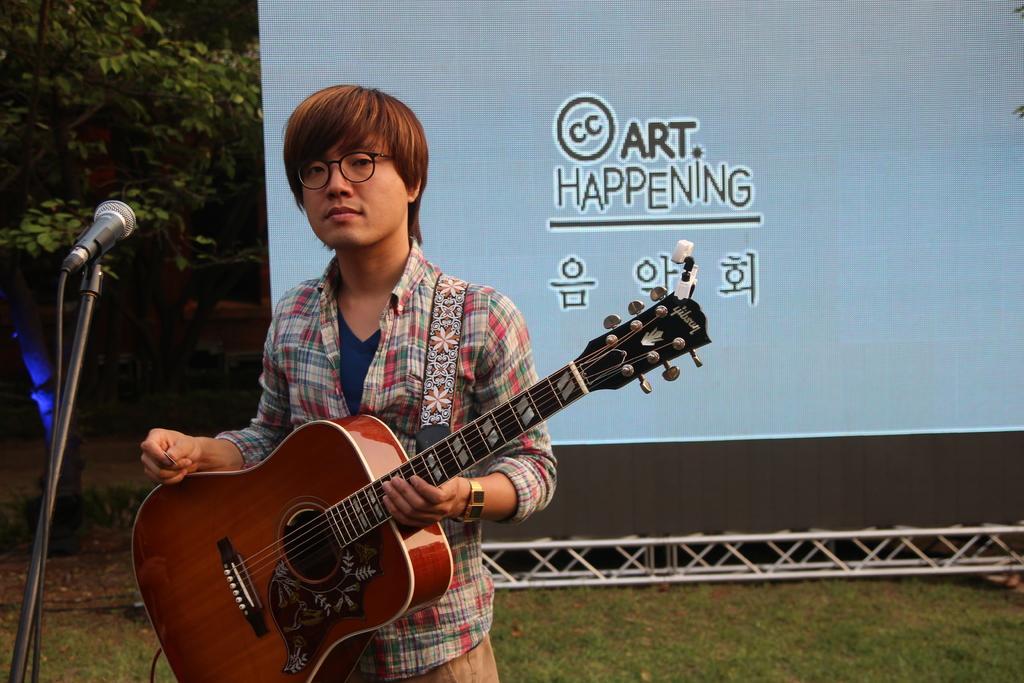Could you give a brief overview of what you see in this image? This persons standing and holding guitar and wear glasses,in front of this person there is a microphone with stand. On the background we can see banner,trees. 